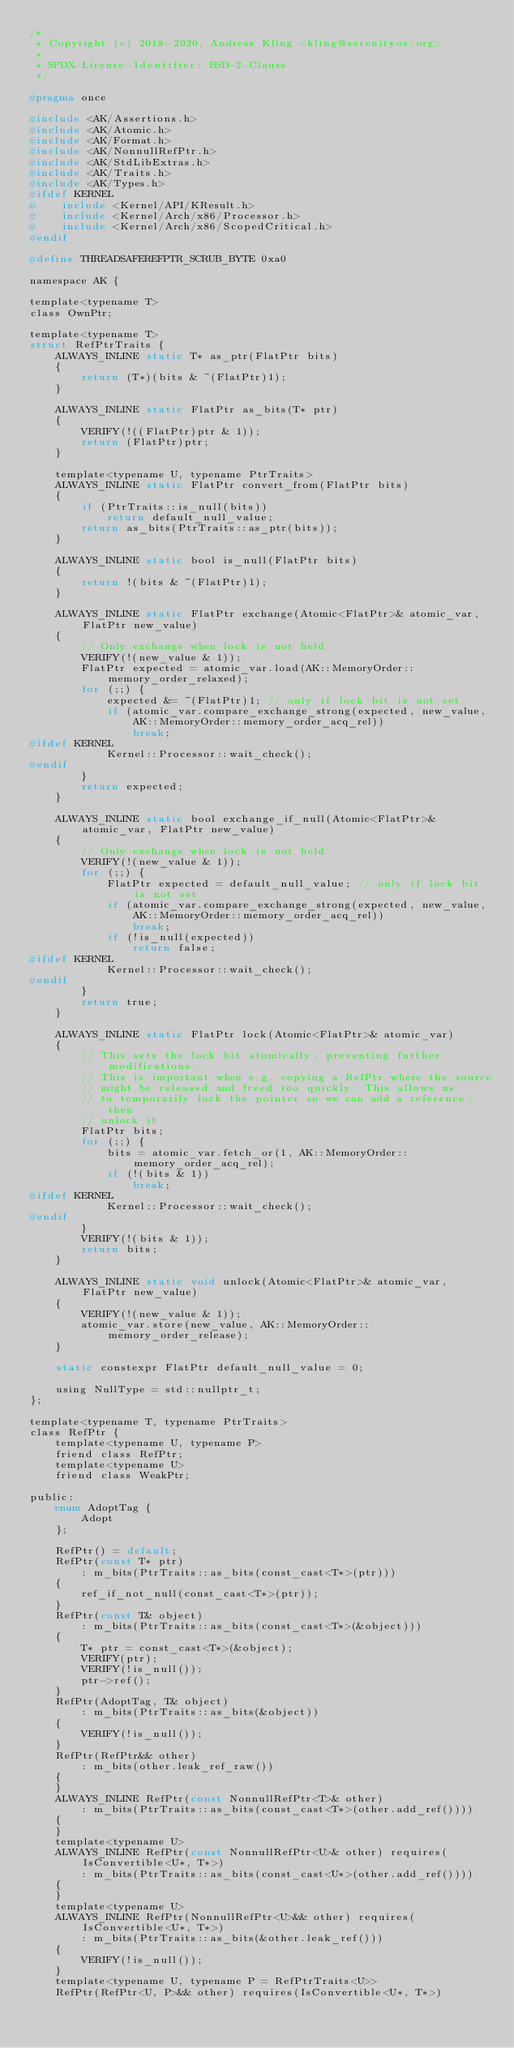<code> <loc_0><loc_0><loc_500><loc_500><_C_>/*
 * Copyright (c) 2018-2020, Andreas Kling <kling@serenityos.org>
 *
 * SPDX-License-Identifier: BSD-2-Clause
 */

#pragma once

#include <AK/Assertions.h>
#include <AK/Atomic.h>
#include <AK/Format.h>
#include <AK/NonnullRefPtr.h>
#include <AK/StdLibExtras.h>
#include <AK/Traits.h>
#include <AK/Types.h>
#ifdef KERNEL
#    include <Kernel/API/KResult.h>
#    include <Kernel/Arch/x86/Processor.h>
#    include <Kernel/Arch/x86/ScopedCritical.h>
#endif

#define THREADSAFEREFPTR_SCRUB_BYTE 0xa0

namespace AK {

template<typename T>
class OwnPtr;

template<typename T>
struct RefPtrTraits {
    ALWAYS_INLINE static T* as_ptr(FlatPtr bits)
    {
        return (T*)(bits & ~(FlatPtr)1);
    }

    ALWAYS_INLINE static FlatPtr as_bits(T* ptr)
    {
        VERIFY(!((FlatPtr)ptr & 1));
        return (FlatPtr)ptr;
    }

    template<typename U, typename PtrTraits>
    ALWAYS_INLINE static FlatPtr convert_from(FlatPtr bits)
    {
        if (PtrTraits::is_null(bits))
            return default_null_value;
        return as_bits(PtrTraits::as_ptr(bits));
    }

    ALWAYS_INLINE static bool is_null(FlatPtr bits)
    {
        return !(bits & ~(FlatPtr)1);
    }

    ALWAYS_INLINE static FlatPtr exchange(Atomic<FlatPtr>& atomic_var, FlatPtr new_value)
    {
        // Only exchange when lock is not held
        VERIFY(!(new_value & 1));
        FlatPtr expected = atomic_var.load(AK::MemoryOrder::memory_order_relaxed);
        for (;;) {
            expected &= ~(FlatPtr)1; // only if lock bit is not set
            if (atomic_var.compare_exchange_strong(expected, new_value, AK::MemoryOrder::memory_order_acq_rel))
                break;
#ifdef KERNEL
            Kernel::Processor::wait_check();
#endif
        }
        return expected;
    }

    ALWAYS_INLINE static bool exchange_if_null(Atomic<FlatPtr>& atomic_var, FlatPtr new_value)
    {
        // Only exchange when lock is not held
        VERIFY(!(new_value & 1));
        for (;;) {
            FlatPtr expected = default_null_value; // only if lock bit is not set
            if (atomic_var.compare_exchange_strong(expected, new_value, AK::MemoryOrder::memory_order_acq_rel))
                break;
            if (!is_null(expected))
                return false;
#ifdef KERNEL
            Kernel::Processor::wait_check();
#endif
        }
        return true;
    }

    ALWAYS_INLINE static FlatPtr lock(Atomic<FlatPtr>& atomic_var)
    {
        // This sets the lock bit atomically, preventing further modifications.
        // This is important when e.g. copying a RefPtr where the source
        // might be released and freed too quickly. This allows us
        // to temporarily lock the pointer so we can add a reference, then
        // unlock it
        FlatPtr bits;
        for (;;) {
            bits = atomic_var.fetch_or(1, AK::MemoryOrder::memory_order_acq_rel);
            if (!(bits & 1))
                break;
#ifdef KERNEL
            Kernel::Processor::wait_check();
#endif
        }
        VERIFY(!(bits & 1));
        return bits;
    }

    ALWAYS_INLINE static void unlock(Atomic<FlatPtr>& atomic_var, FlatPtr new_value)
    {
        VERIFY(!(new_value & 1));
        atomic_var.store(new_value, AK::MemoryOrder::memory_order_release);
    }

    static constexpr FlatPtr default_null_value = 0;

    using NullType = std::nullptr_t;
};

template<typename T, typename PtrTraits>
class RefPtr {
    template<typename U, typename P>
    friend class RefPtr;
    template<typename U>
    friend class WeakPtr;

public:
    enum AdoptTag {
        Adopt
    };

    RefPtr() = default;
    RefPtr(const T* ptr)
        : m_bits(PtrTraits::as_bits(const_cast<T*>(ptr)))
    {
        ref_if_not_null(const_cast<T*>(ptr));
    }
    RefPtr(const T& object)
        : m_bits(PtrTraits::as_bits(const_cast<T*>(&object)))
    {
        T* ptr = const_cast<T*>(&object);
        VERIFY(ptr);
        VERIFY(!is_null());
        ptr->ref();
    }
    RefPtr(AdoptTag, T& object)
        : m_bits(PtrTraits::as_bits(&object))
    {
        VERIFY(!is_null());
    }
    RefPtr(RefPtr&& other)
        : m_bits(other.leak_ref_raw())
    {
    }
    ALWAYS_INLINE RefPtr(const NonnullRefPtr<T>& other)
        : m_bits(PtrTraits::as_bits(const_cast<T*>(other.add_ref())))
    {
    }
    template<typename U>
    ALWAYS_INLINE RefPtr(const NonnullRefPtr<U>& other) requires(IsConvertible<U*, T*>)
        : m_bits(PtrTraits::as_bits(const_cast<U*>(other.add_ref())))
    {
    }
    template<typename U>
    ALWAYS_INLINE RefPtr(NonnullRefPtr<U>&& other) requires(IsConvertible<U*, T*>)
        : m_bits(PtrTraits::as_bits(&other.leak_ref()))
    {
        VERIFY(!is_null());
    }
    template<typename U, typename P = RefPtrTraits<U>>
    RefPtr(RefPtr<U, P>&& other) requires(IsConvertible<U*, T*>)</code> 